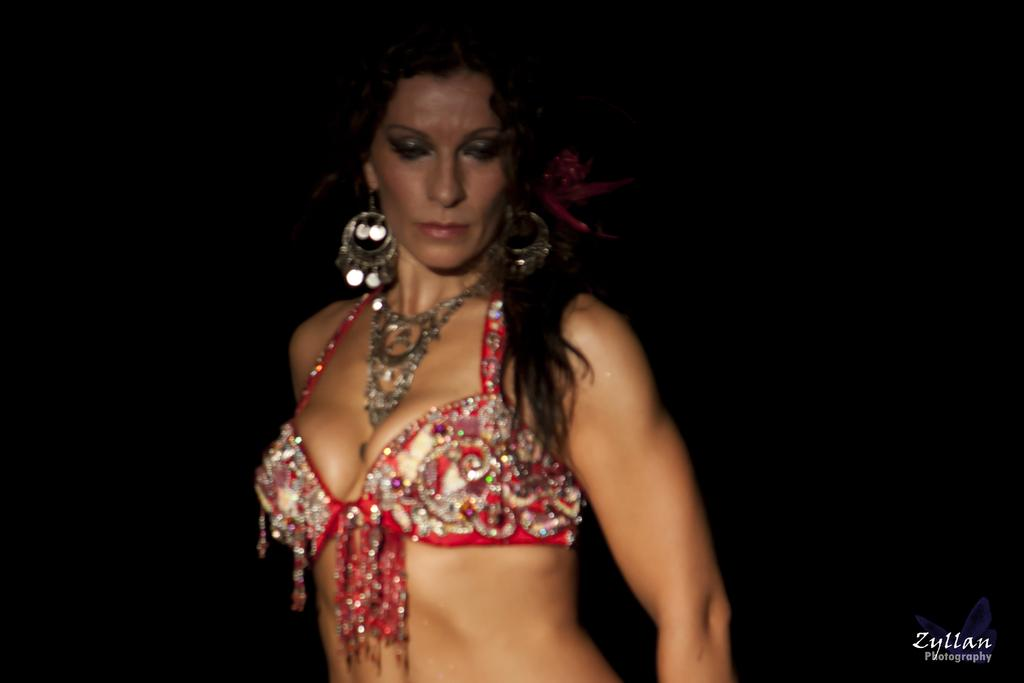Who is the main subject in the image? There is a woman in the front of the image. What can be observed about the background of the image? The background of the image is dark. Where is the logo located in the image? The logo is at the right bottom of the image. What else is present at the right bottom of the image? There is some text at the right bottom of the image. What type of school is depicted in the image? There is no school present in the image. How low is the form in the image? There is no form present in the image. 